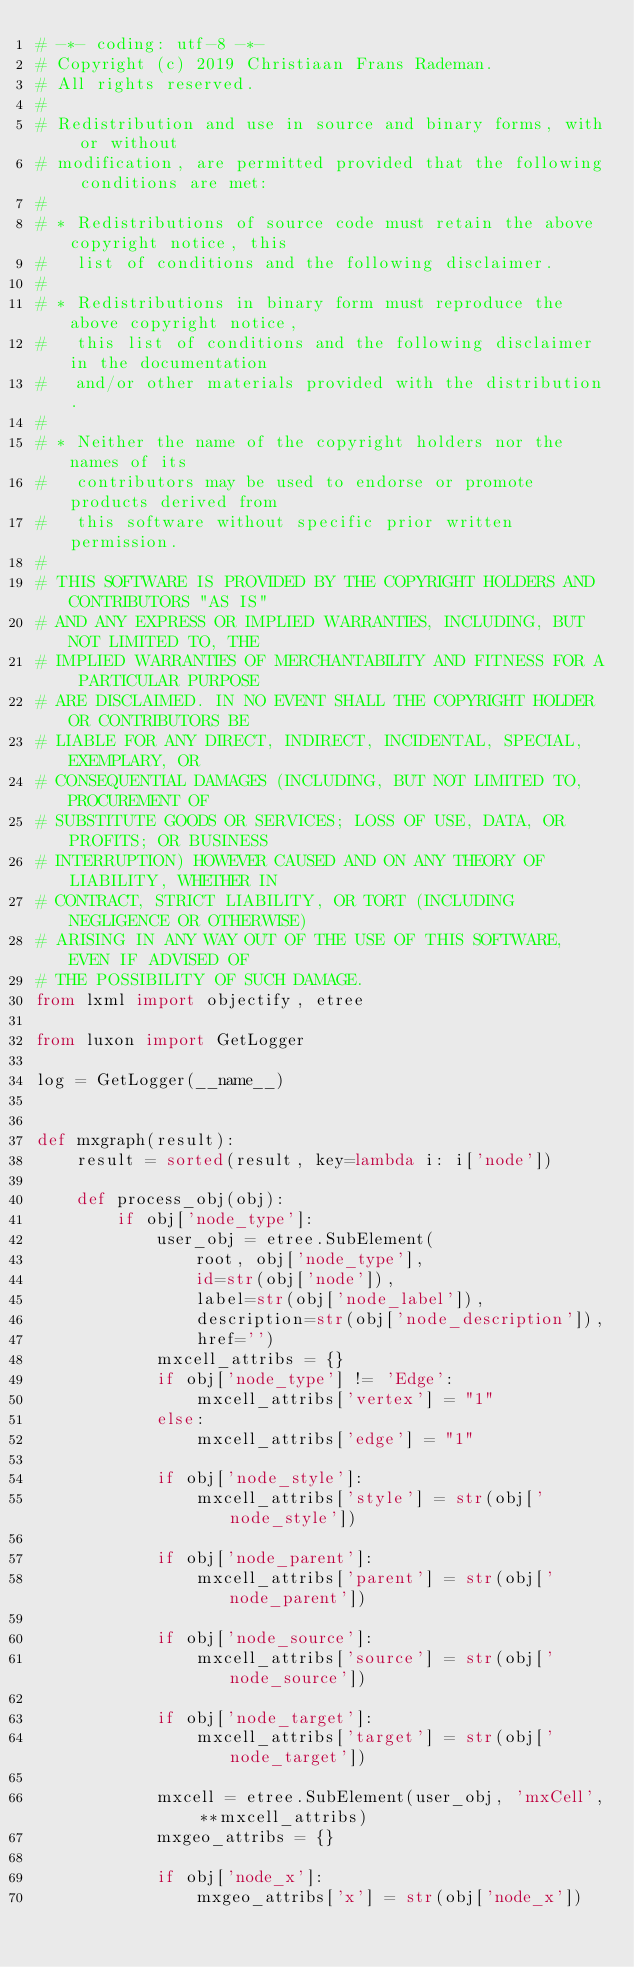Convert code to text. <code><loc_0><loc_0><loc_500><loc_500><_Python_># -*- coding: utf-8 -*-
# Copyright (c) 2019 Christiaan Frans Rademan.
# All rights reserved.
#
# Redistribution and use in source and binary forms, with or without
# modification, are permitted provided that the following conditions are met:
#
# * Redistributions of source code must retain the above copyright notice, this
#   list of conditions and the following disclaimer.
#
# * Redistributions in binary form must reproduce the above copyright notice,
#   this list of conditions and the following disclaimer in the documentation
#   and/or other materials provided with the distribution.
#
# * Neither the name of the copyright holders nor the names of its
#   contributors may be used to endorse or promote products derived from
#   this software without specific prior written permission.
#
# THIS SOFTWARE IS PROVIDED BY THE COPYRIGHT HOLDERS AND CONTRIBUTORS "AS IS"
# AND ANY EXPRESS OR IMPLIED WARRANTIES, INCLUDING, BUT NOT LIMITED TO, THE
# IMPLIED WARRANTIES OF MERCHANTABILITY AND FITNESS FOR A PARTICULAR PURPOSE
# ARE DISCLAIMED. IN NO EVENT SHALL THE COPYRIGHT HOLDER OR CONTRIBUTORS BE
# LIABLE FOR ANY DIRECT, INDIRECT, INCIDENTAL, SPECIAL, EXEMPLARY, OR
# CONSEQUENTIAL DAMAGES (INCLUDING, BUT NOT LIMITED TO, PROCUREMENT OF
# SUBSTITUTE GOODS OR SERVICES; LOSS OF USE, DATA, OR PROFITS; OR BUSINESS
# INTERRUPTION) HOWEVER CAUSED AND ON ANY THEORY OF LIABILITY, WHETHER IN
# CONTRACT, STRICT LIABILITY, OR TORT (INCLUDING NEGLIGENCE OR OTHERWISE)
# ARISING IN ANY WAY OUT OF THE USE OF THIS SOFTWARE, EVEN IF ADVISED OF
# THE POSSIBILITY OF SUCH DAMAGE.
from lxml import objectify, etree

from luxon import GetLogger

log = GetLogger(__name__)


def mxgraph(result):
    result = sorted(result, key=lambda i: i['node'])

    def process_obj(obj):
        if obj['node_type']:
            user_obj = etree.SubElement(
                root, obj['node_type'],
                id=str(obj['node']),
                label=str(obj['node_label']),
                description=str(obj['node_description']),
                href='')
            mxcell_attribs = {}
            if obj['node_type'] != 'Edge':
                mxcell_attribs['vertex'] = "1"
            else:
                mxcell_attribs['edge'] = "1"

            if obj['node_style']:
                mxcell_attribs['style'] = str(obj['node_style'])

            if obj['node_parent']:
                mxcell_attribs['parent'] = str(obj['node_parent'])

            if obj['node_source']:
                mxcell_attribs['source'] = str(obj['node_source'])

            if obj['node_target']:
                mxcell_attribs['target'] = str(obj['node_target'])

            mxcell = etree.SubElement(user_obj, 'mxCell', **mxcell_attribs)
            mxgeo_attribs = {}

            if obj['node_x']:
                mxgeo_attribs['x'] = str(obj['node_x'])</code> 